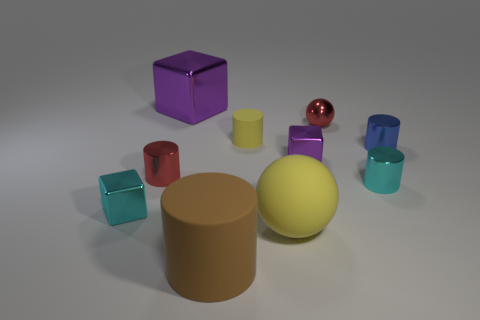Subtract all red cylinders. How many cylinders are left? 4 Subtract all large brown cylinders. How many cylinders are left? 4 Subtract all gray cylinders. Subtract all yellow balls. How many cylinders are left? 5 Subtract all blocks. How many objects are left? 7 Add 2 red metallic things. How many red metallic things exist? 4 Subtract 0 cyan balls. How many objects are left? 10 Subtract all tiny red shiny cylinders. Subtract all tiny objects. How many objects are left? 2 Add 7 tiny metallic spheres. How many tiny metallic spheres are left? 8 